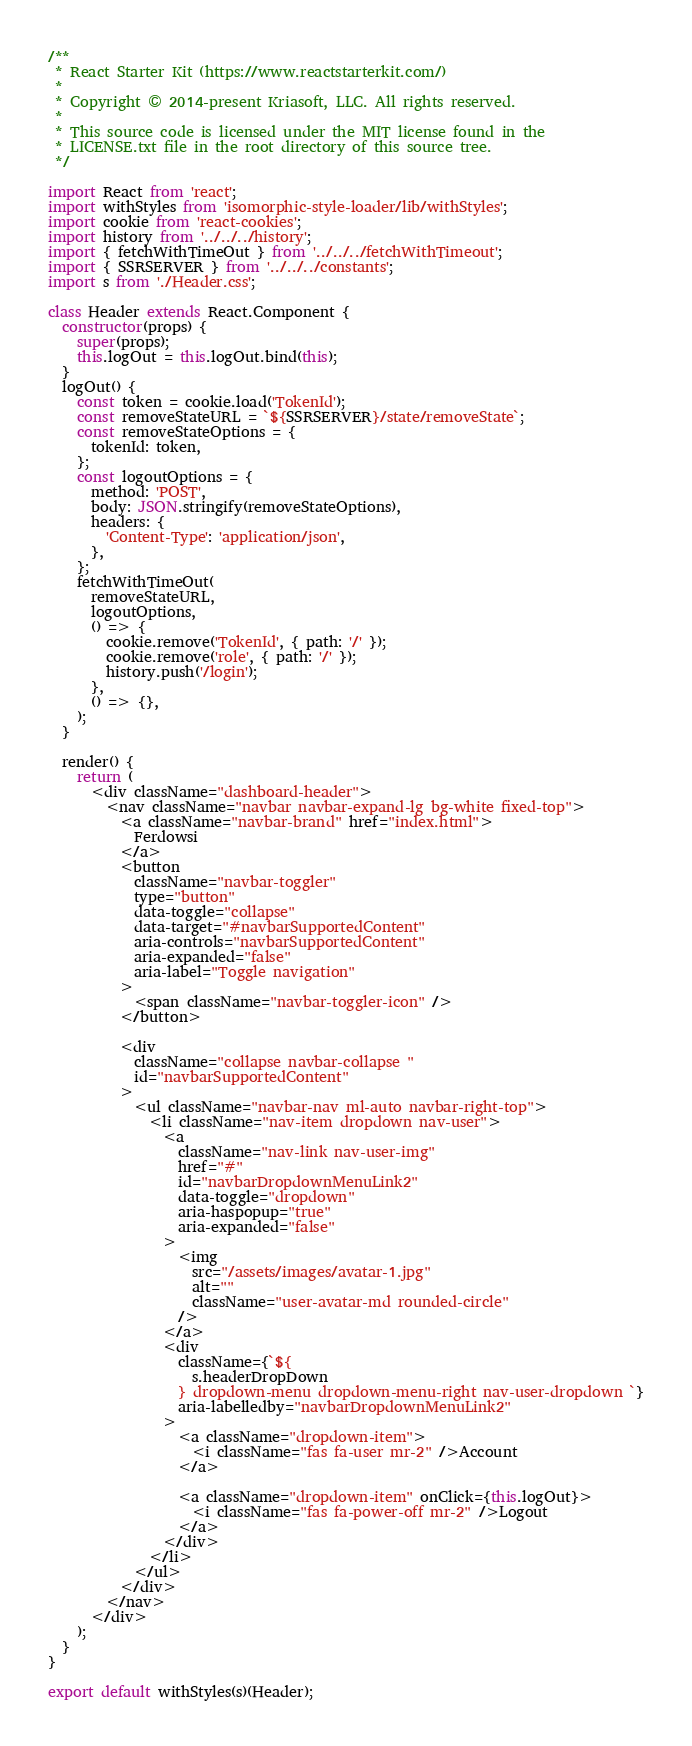Convert code to text. <code><loc_0><loc_0><loc_500><loc_500><_JavaScript_>/**
 * React Starter Kit (https://www.reactstarterkit.com/)
 *
 * Copyright © 2014-present Kriasoft, LLC. All rights reserved.
 *
 * This source code is licensed under the MIT license found in the
 * LICENSE.txt file in the root directory of this source tree.
 */

import React from 'react';
import withStyles from 'isomorphic-style-loader/lib/withStyles';
import cookie from 'react-cookies';
import history from '../../../history';
import { fetchWithTimeOut } from '../../../fetchWithTimeout';
import { SSRSERVER } from '../../../constants';
import s from './Header.css';

class Header extends React.Component {
  constructor(props) {
    super(props);
    this.logOut = this.logOut.bind(this);
  }
  logOut() {
    const token = cookie.load('TokenId');
    const removeStateURL = `${SSRSERVER}/state/removeState`;
    const removeStateOptions = {
      tokenId: token,
    };
    const logoutOptions = {
      method: 'POST',
      body: JSON.stringify(removeStateOptions),
      headers: {
        'Content-Type': 'application/json',
      },
    };
    fetchWithTimeOut(
      removeStateURL,
      logoutOptions,
      () => {
        cookie.remove('TokenId', { path: '/' });
        cookie.remove('role', { path: '/' });
        history.push('/login');
      },
      () => {},
    );
  }

  render() {
    return (
      <div className="dashboard-header">
        <nav className="navbar navbar-expand-lg bg-white fixed-top">
          <a className="navbar-brand" href="index.html">
            Ferdowsi
          </a>
          <button
            className="navbar-toggler"
            type="button"
            data-toggle="collapse"
            data-target="#navbarSupportedContent"
            aria-controls="navbarSupportedContent"
            aria-expanded="false"
            aria-label="Toggle navigation"
          >
            <span className="navbar-toggler-icon" />
          </button>

          <div
            className="collapse navbar-collapse "
            id="navbarSupportedContent"
          >
            <ul className="navbar-nav ml-auto navbar-right-top">
              <li className="nav-item dropdown nav-user">
                <a
                  className="nav-link nav-user-img"
                  href="#"
                  id="navbarDropdownMenuLink2"
                  data-toggle="dropdown"
                  aria-haspopup="true"
                  aria-expanded="false"
                >
                  <img
                    src="/assets/images/avatar-1.jpg"
                    alt=""
                    className="user-avatar-md rounded-circle"
                  />
                </a>
                <div
                  className={`${
                    s.headerDropDown
                  } dropdown-menu dropdown-menu-right nav-user-dropdown `}
                  aria-labelledby="navbarDropdownMenuLink2"
                >
                  <a className="dropdown-item">
                    <i className="fas fa-user mr-2" />Account
                  </a>

                  <a className="dropdown-item" onClick={this.logOut}>
                    <i className="fas fa-power-off mr-2" />Logout
                  </a>
                </div>
              </li>
            </ul>
          </div>
        </nav>
      </div>
    );
  }
}

export default withStyles(s)(Header);
</code> 